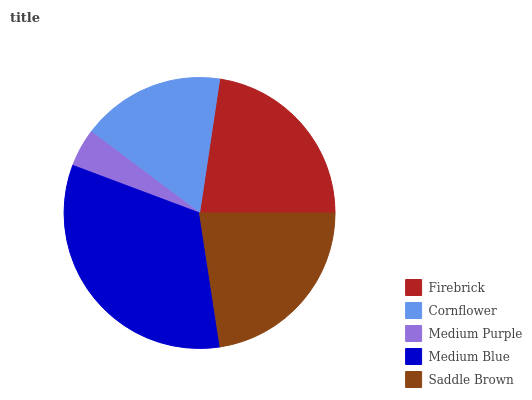Is Medium Purple the minimum?
Answer yes or no. Yes. Is Medium Blue the maximum?
Answer yes or no. Yes. Is Cornflower the minimum?
Answer yes or no. No. Is Cornflower the maximum?
Answer yes or no. No. Is Firebrick greater than Cornflower?
Answer yes or no. Yes. Is Cornflower less than Firebrick?
Answer yes or no. Yes. Is Cornflower greater than Firebrick?
Answer yes or no. No. Is Firebrick less than Cornflower?
Answer yes or no. No. Is Saddle Brown the high median?
Answer yes or no. Yes. Is Saddle Brown the low median?
Answer yes or no. Yes. Is Firebrick the high median?
Answer yes or no. No. Is Medium Blue the low median?
Answer yes or no. No. 